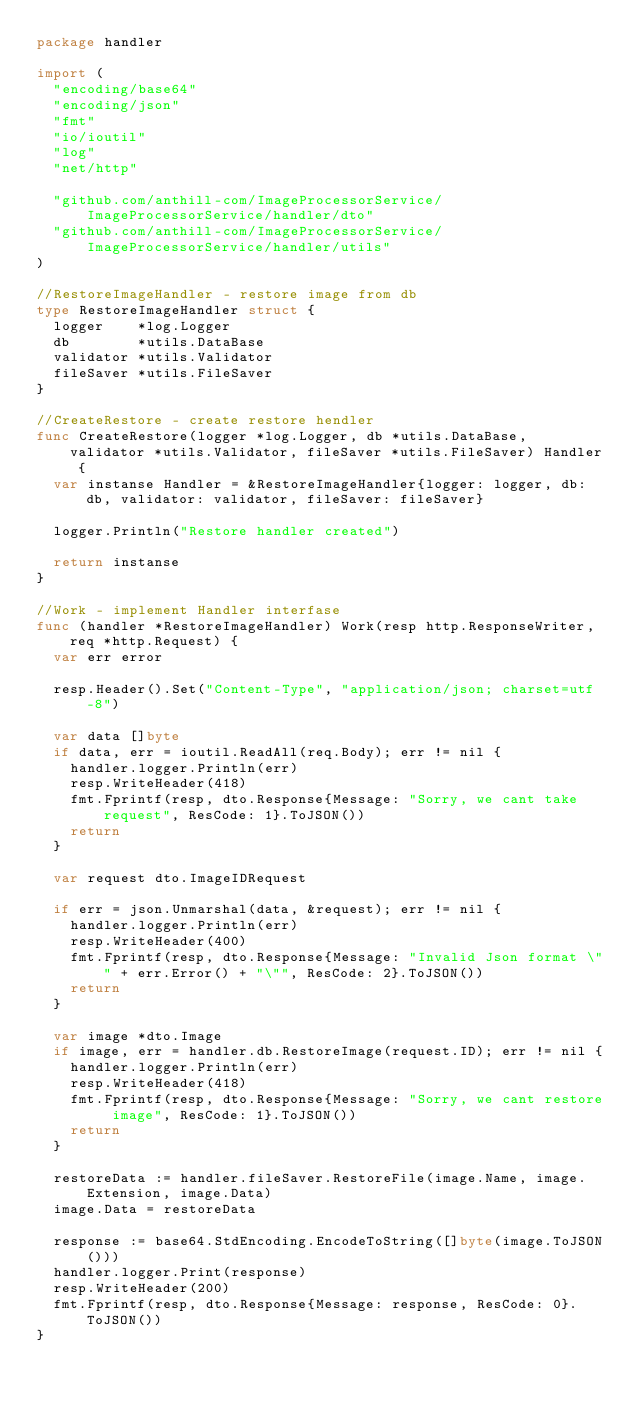<code> <loc_0><loc_0><loc_500><loc_500><_Go_>package handler

import (
	"encoding/base64"
	"encoding/json"
	"fmt"
	"io/ioutil"
	"log"
	"net/http"

	"github.com/anthill-com/ImageProcessorService/ImageProcessorService/handler/dto"
	"github.com/anthill-com/ImageProcessorService/ImageProcessorService/handler/utils"
)

//RestoreImageHandler - restore image from db
type RestoreImageHandler struct {
	logger    *log.Logger
	db        *utils.DataBase
	validator *utils.Validator
	fileSaver *utils.FileSaver
}

//CreateRestore - create restore hendler
func CreateRestore(logger *log.Logger, db *utils.DataBase, validator *utils.Validator, fileSaver *utils.FileSaver) Handler {
	var instanse Handler = &RestoreImageHandler{logger: logger, db: db, validator: validator, fileSaver: fileSaver}

	logger.Println("Restore handler created")

	return instanse
}

//Work - implement Handler interfase
func (handler *RestoreImageHandler) Work(resp http.ResponseWriter, req *http.Request) {
	var err error

	resp.Header().Set("Content-Type", "application/json; charset=utf-8")

	var data []byte
	if data, err = ioutil.ReadAll(req.Body); err != nil {
		handler.logger.Println(err)
		resp.WriteHeader(418)
		fmt.Fprintf(resp, dto.Response{Message: "Sorry, we cant take request", ResCode: 1}.ToJSON())
		return
	}

	var request dto.ImageIDRequest

	if err = json.Unmarshal(data, &request); err != nil {
		handler.logger.Println(err)
		resp.WriteHeader(400)
		fmt.Fprintf(resp, dto.Response{Message: "Invalid Json format \"" + err.Error() + "\"", ResCode: 2}.ToJSON())
		return
	}

	var image *dto.Image
	if image, err = handler.db.RestoreImage(request.ID); err != nil {
		handler.logger.Println(err)
		resp.WriteHeader(418)
		fmt.Fprintf(resp, dto.Response{Message: "Sorry, we cant restore image", ResCode: 1}.ToJSON())
		return
	}

	restoreData := handler.fileSaver.RestoreFile(image.Name, image.Extension, image.Data)
	image.Data = restoreData

	response := base64.StdEncoding.EncodeToString([]byte(image.ToJSON()))
	handler.logger.Print(response)
	resp.WriteHeader(200)
	fmt.Fprintf(resp, dto.Response{Message: response, ResCode: 0}.ToJSON())
}
</code> 